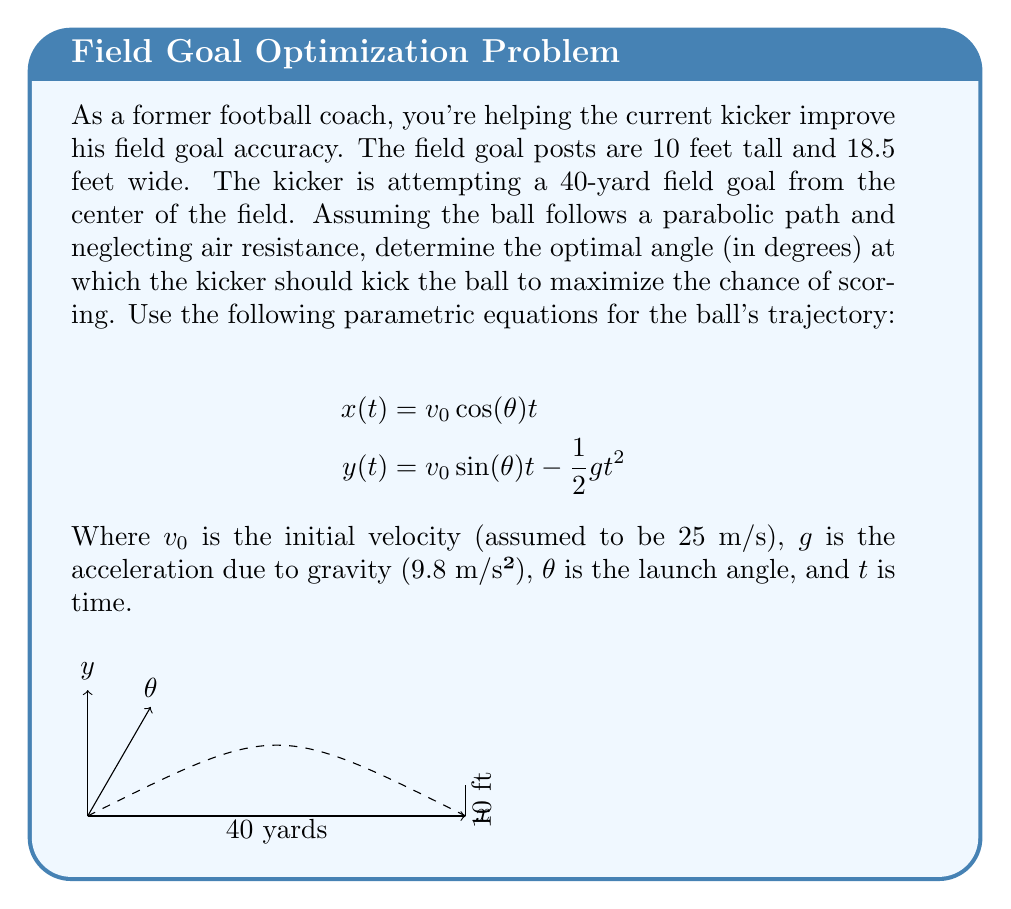Can you answer this question? Let's approach this step-by-step:

1) First, we need to convert all measurements to meters:
   40 yards = 36.576 m
   10 feet = 3.048 m

2) We want the ball to reach the crossbar (y = 3.048 m) when x = 36.576 m.

3) Using the parametric equations, we can eliminate t:
   $$x = v_0 \cos(\theta) t$$
   $$t = \frac{x}{v_0 \cos(\theta)}$$

   Substituting this into the y equation:
   $$y = v_0 \sin(\theta) \frac{x}{v_0 \cos(\theta)} - \frac{1}{2}g\left(\frac{x}{v_0 \cos(\theta)}\right)^2$$

4) Simplify:
   $$y = x \tan(\theta) - \frac{gx^2}{2v_0^2 \cos^2(\theta)}$$

5) Now, we want y = 3.048 when x = 36.576. Substituting these values:
   $$3.048 = 36.576 \tan(\theta) - \frac{9.8(36.576)^2}{2(25)^2 \cos^2(\theta)}$$

6) This equation can be solved numerically. Using a calculator or computer algebra system, we find:
   $$\theta \approx 14.47°$$

7) To maximize the chance of scoring, we want the ball to cross the plane of the goal posts at the middle of the crossbar. This angle ensures that.
Answer: $14.47°$ 